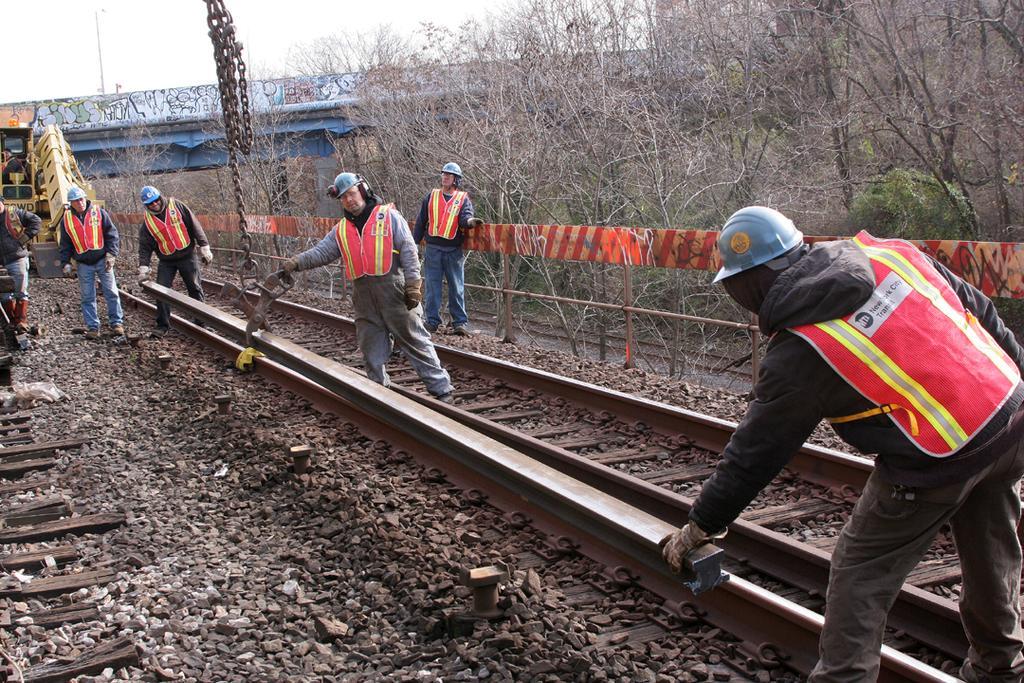In one or two sentences, can you explain what this image depicts? In the picture we can see some people are constructing a railway track and they are in jackets and helmets and behind them, we can see some dried plants and behind it, we can see a bridge on it we can see a pole with lights to it and behind it we can see a sky. 